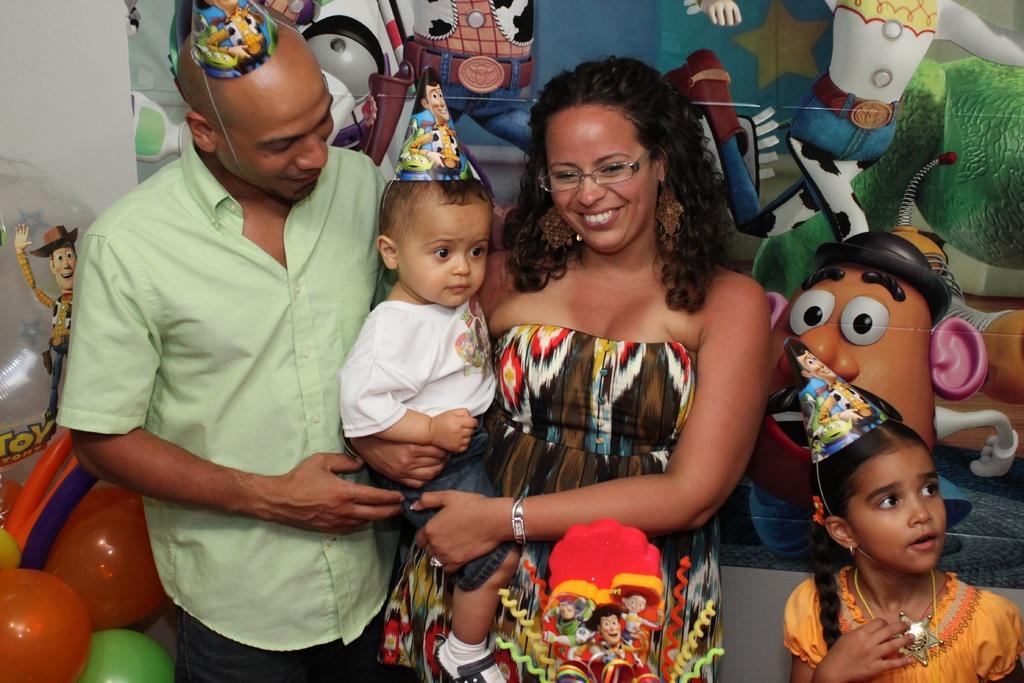Please provide a concise description of this image. In this image there is a man standing, he is wearing a cap, there is a woman standing, there is a girl towards the bottom of the image, she is wearing a cap, there is a boy, he is wearing a cap, there are balloons towards the bottom of the image, there is an object towards the left of the image, at the background of the image there is a wall, there is an object on the wall. 